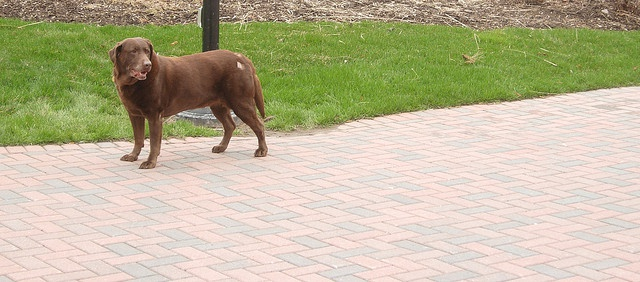Describe the objects in this image and their specific colors. I can see a dog in tan, maroon, brown, gray, and black tones in this image. 